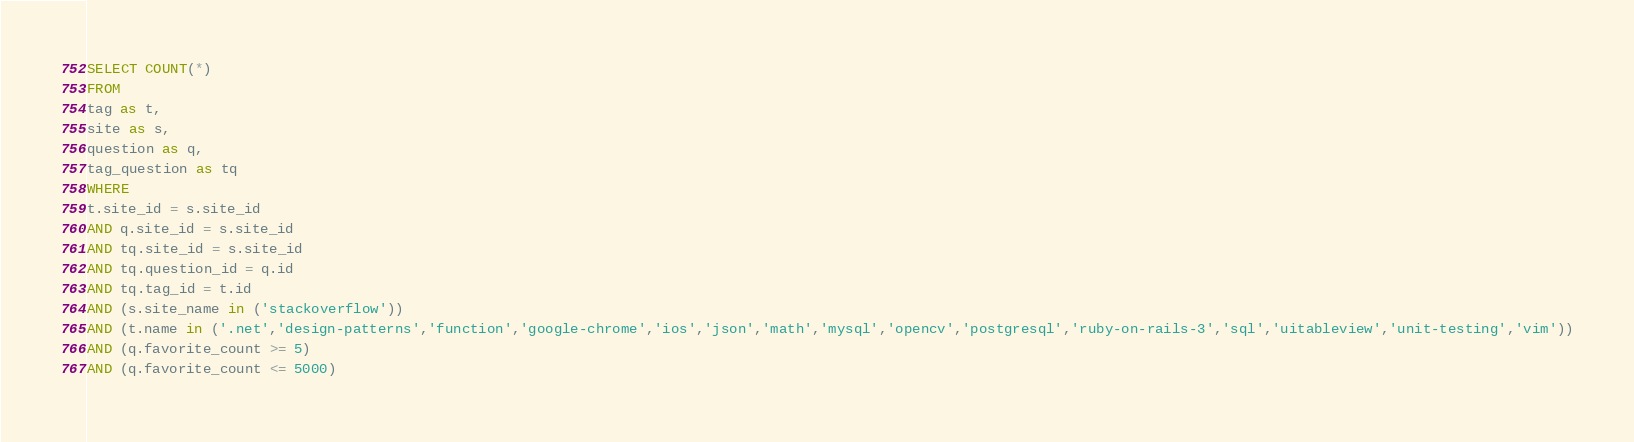Convert code to text. <code><loc_0><loc_0><loc_500><loc_500><_SQL_>SELECT COUNT(*)
FROM
tag as t,
site as s,
question as q,
tag_question as tq
WHERE
t.site_id = s.site_id
AND q.site_id = s.site_id
AND tq.site_id = s.site_id
AND tq.question_id = q.id
AND tq.tag_id = t.id
AND (s.site_name in ('stackoverflow'))
AND (t.name in ('.net','design-patterns','function','google-chrome','ios','json','math','mysql','opencv','postgresql','ruby-on-rails-3','sql','uitableview','unit-testing','vim'))
AND (q.favorite_count >= 5)
AND (q.favorite_count <= 5000)
</code> 